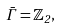Convert formula to latex. <formula><loc_0><loc_0><loc_500><loc_500>\bar { \Gamma } = \mathbb { Z } _ { 2 } ,</formula> 